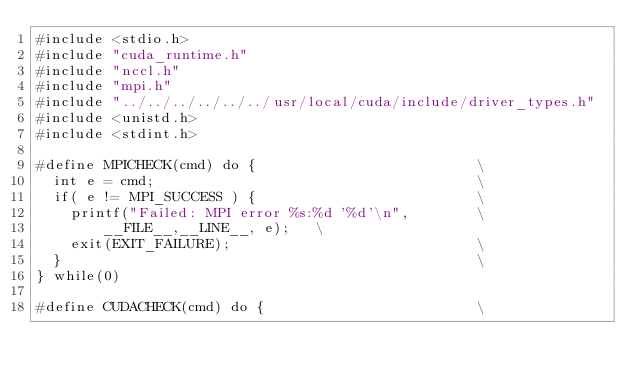<code> <loc_0><loc_0><loc_500><loc_500><_Cuda_>#include <stdio.h>
#include "cuda_runtime.h"
#include "nccl.h"
#include "mpi.h"
#include "../../../../../../usr/local/cuda/include/driver_types.h"
#include <unistd.h>
#include <stdint.h>

#define MPICHECK(cmd) do {                          \
  int e = cmd;                                      \
  if( e != MPI_SUCCESS ) {                          \
    printf("Failed: MPI error %s:%d '%d'\n",        \
        __FILE__,__LINE__, e);   \
    exit(EXIT_FAILURE);                             \
  }                                                 \
} while(0)

#define CUDACHECK(cmd) do {                         \</code> 